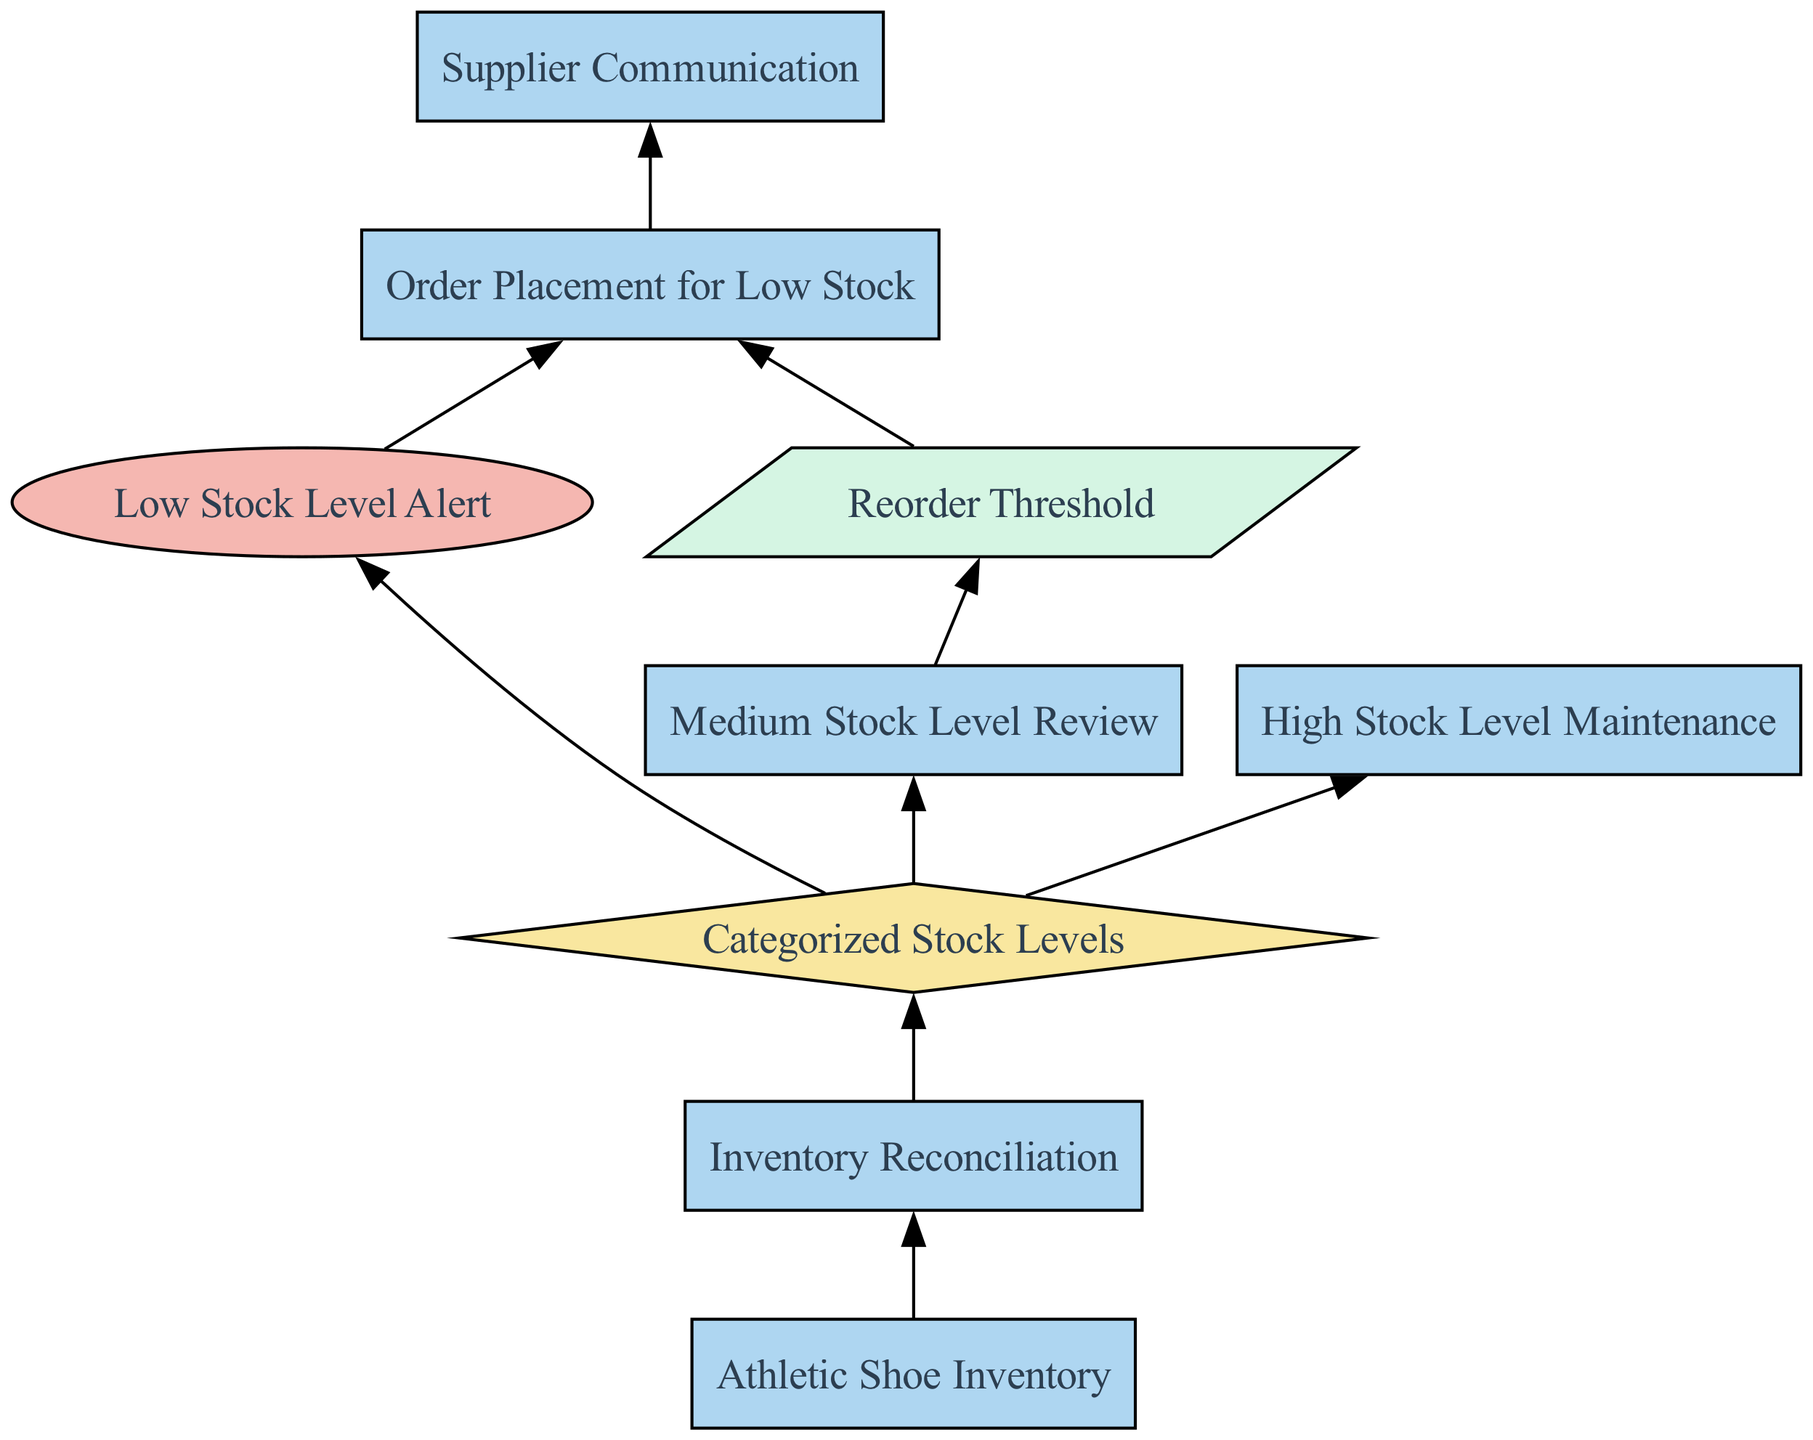What is the first process in the flow chart? The first process listed in the diagram is "Athletic Shoe Inventory," which represents the overall management of all athletic shoe stock levels.
Answer: Athletic Shoe Inventory How many types of elements are represented in the diagram? There are four types of elements in the diagram: Process, Decision, Trigger, and Parameter.
Answer: Four What triggers the "Order Placement for Low Stock"? The "Order Placement for Low Stock" process is triggered by the "Low Stock Level Alert," indicating a need to reorder when stock falls below the threshold.
Answer: Low Stock Level Alert What is reviewed periodically in the inventory management process? The "Medium Stock Level Review" process is conducted periodically to assess if there is a need for reordering based on stock levels.
Answer: Medium Stock Level Review Which process comes before "Supplier Communication"? "Order Placement for Low Stock" precedes "Supplier Communication," as it involves placing orders prior to negotiating with suppliers.
Answer: Order Placement for Low Stock What happens to high stock levels in the diagram? The "High Stock Level Maintenance" process is responsible for managing high inventory levels to prevent overstock situations.
Answer: High Stock Level Maintenance What is the relationship between "Inventory Reconciliation" and "Categorized Stock Levels"? "Inventory Reconciliation" is connected to "Categorized Stock Levels," suggesting that inventory checks ensure the recorded levels align with the categorized stock status.
Answer: Inventory Reconciliation Which process is directly linked to the "Reorder Threshold"? The "Reorder Threshold" is directly linked to "Order Placement for Low Stock," as it defines the point at which new inventory should be ordered for low stock.
Answer: Order Placement for Low Stock How many edges connect to the "Categorized Stock Levels" decision node? There are three edges connecting to the "Categorized Stock Levels" decision node, showing it branches out to low, medium, and high stock processes.
Answer: Three 